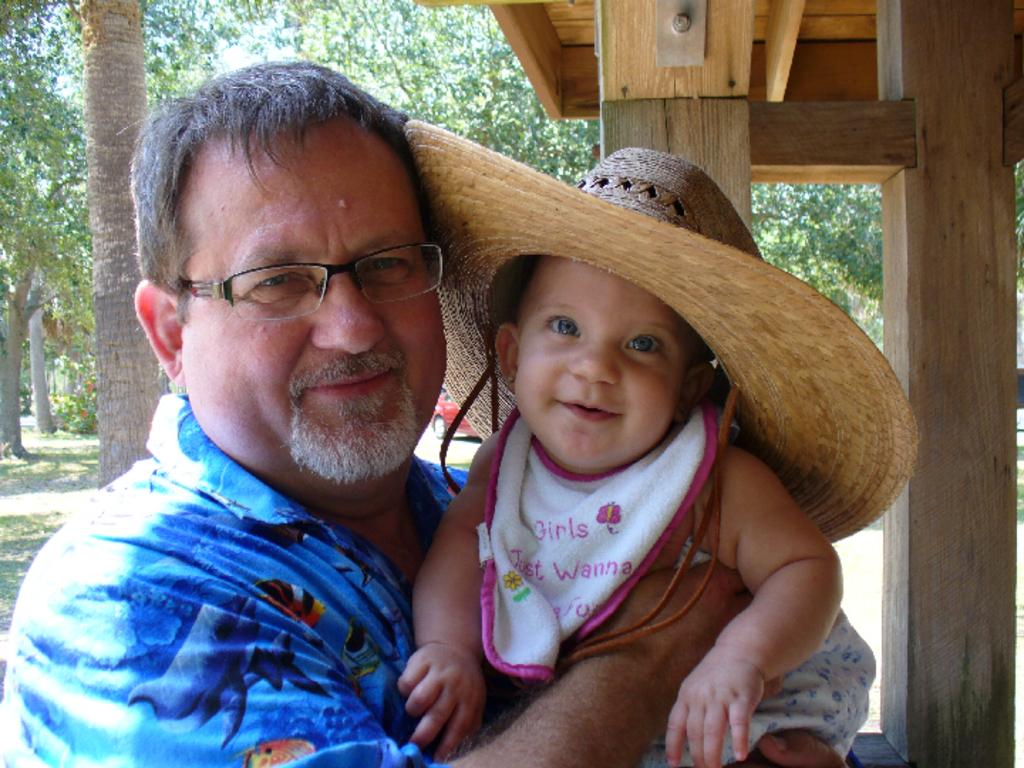What is the main subject of the image? The main subject of the image is a man. What is the man wearing in the image? The man is wearing spectacles in the image. What is the man doing in the image? The man is holding a child in the image. How are the man and the child feeling in the image? Both the man and the child are smiling in the image. What can be seen in the background of the image? There are trees and a car in the background of the image. What type of haircut does the woman in the image have? There is no woman present in the image; it features a man holding a child. Can you describe the breath of the man in the image? There is no information about the man's breath in the image, as it is a still photograph. 